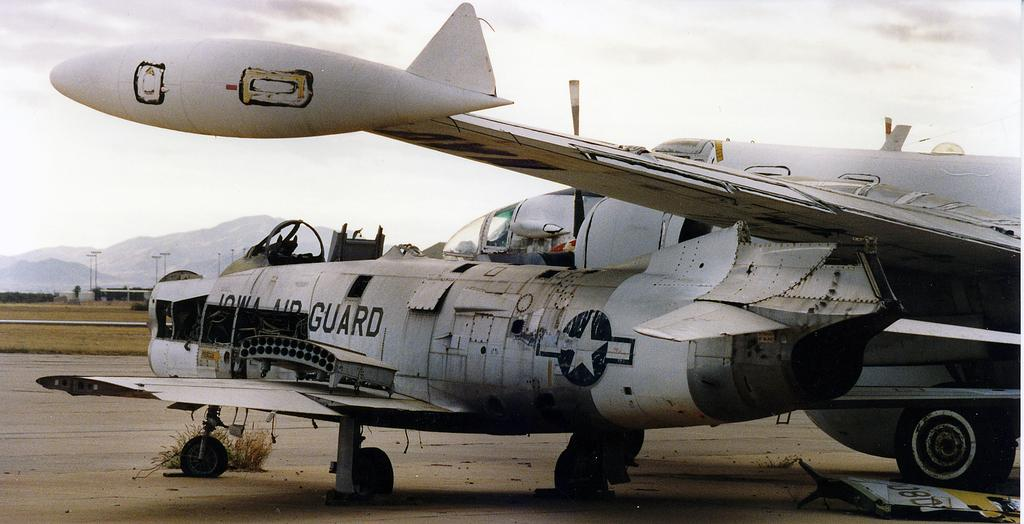What is the main subject of the image? The main subject of the image is planes. Can you describe the color of the planes? The planes are white in color. What is located at the bottom of the image? There is a road at the bottom of the image. What can be seen in the background of the image? There are mountains and poles in the background of the image. What is visible in the sky at the top of the image? There are clouds in the sky at the top of the image. What type of cord is hanging from the plane in the image? There is no cord hanging from the plane in the image; it is a white plane with no visible attachments. What season is depicted in the image? The image does not provide any specific information about the season, as there are no seasonal elements present. 